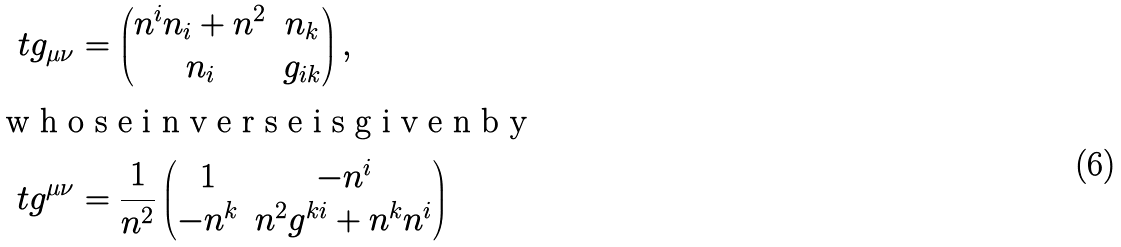Convert formula to latex. <formula><loc_0><loc_0><loc_500><loc_500>\ t g _ { \mu \nu } & = \begin{pmatrix} n ^ { i } n _ { i } + n ^ { 2 } & n _ { k } \\ n _ { i } & g _ { i k } \end{pmatrix} , \\ \intertext { w h o s e i n v e r s e i s g i v e n b y } \ t g ^ { \mu \nu } & = \frac { 1 } { n ^ { 2 } } \begin{pmatrix} 1 & - n ^ { i } \\ - n ^ { k } & n ^ { 2 } g ^ { k i } + n ^ { k } n ^ { i } \end{pmatrix}</formula> 